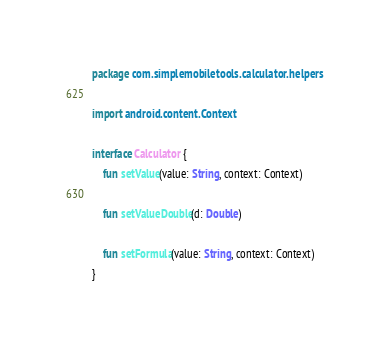Convert code to text. <code><loc_0><loc_0><loc_500><loc_500><_Kotlin_>package com.simplemobiletools.calculator.helpers

import android.content.Context

interface Calculator {
    fun setValue(value: String, context: Context)

    fun setValueDouble(d: Double)

    fun setFormula(value: String, context: Context)
}
</code> 